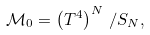Convert formula to latex. <formula><loc_0><loc_0><loc_500><loc_500>\mathcal { M } _ { 0 } = \left ( T ^ { 4 } \right ) ^ { N } \, / S _ { N } ,</formula> 